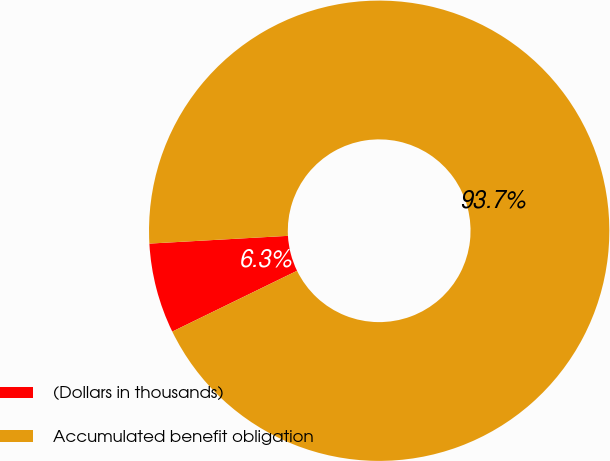Convert chart. <chart><loc_0><loc_0><loc_500><loc_500><pie_chart><fcel>(Dollars in thousands)<fcel>Accumulated benefit obligation<nl><fcel>6.33%<fcel>93.67%<nl></chart> 